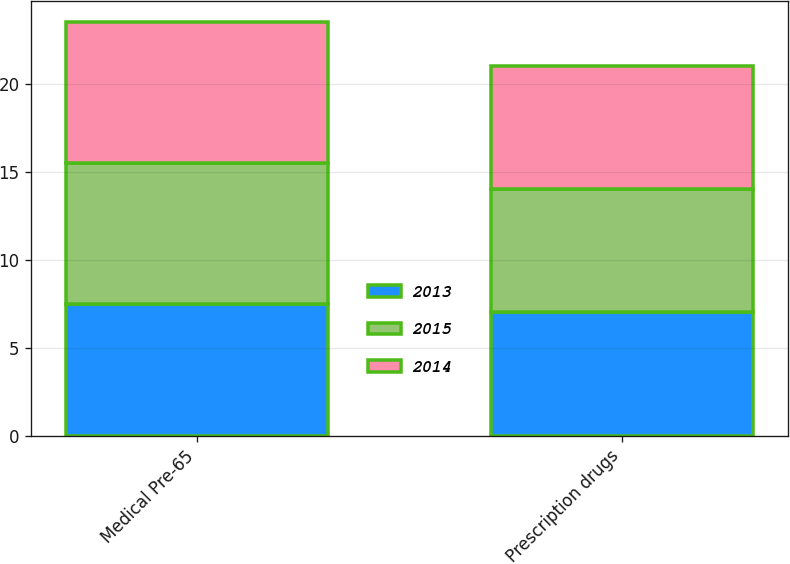<chart> <loc_0><loc_0><loc_500><loc_500><stacked_bar_chart><ecel><fcel>Medical Pre-65<fcel>Prescription drugs<nl><fcel>2013<fcel>7.5<fcel>7<nl><fcel>2015<fcel>8<fcel>7<nl><fcel>2014<fcel>8<fcel>7<nl></chart> 